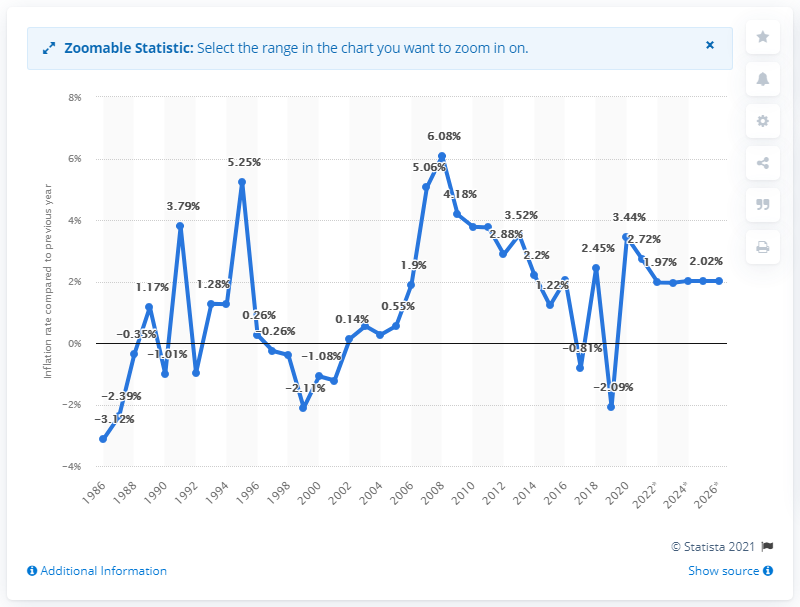Outline some significant characteristics in this image. In 2020, Saudi Arabia's inflation rate was 3.44%. 